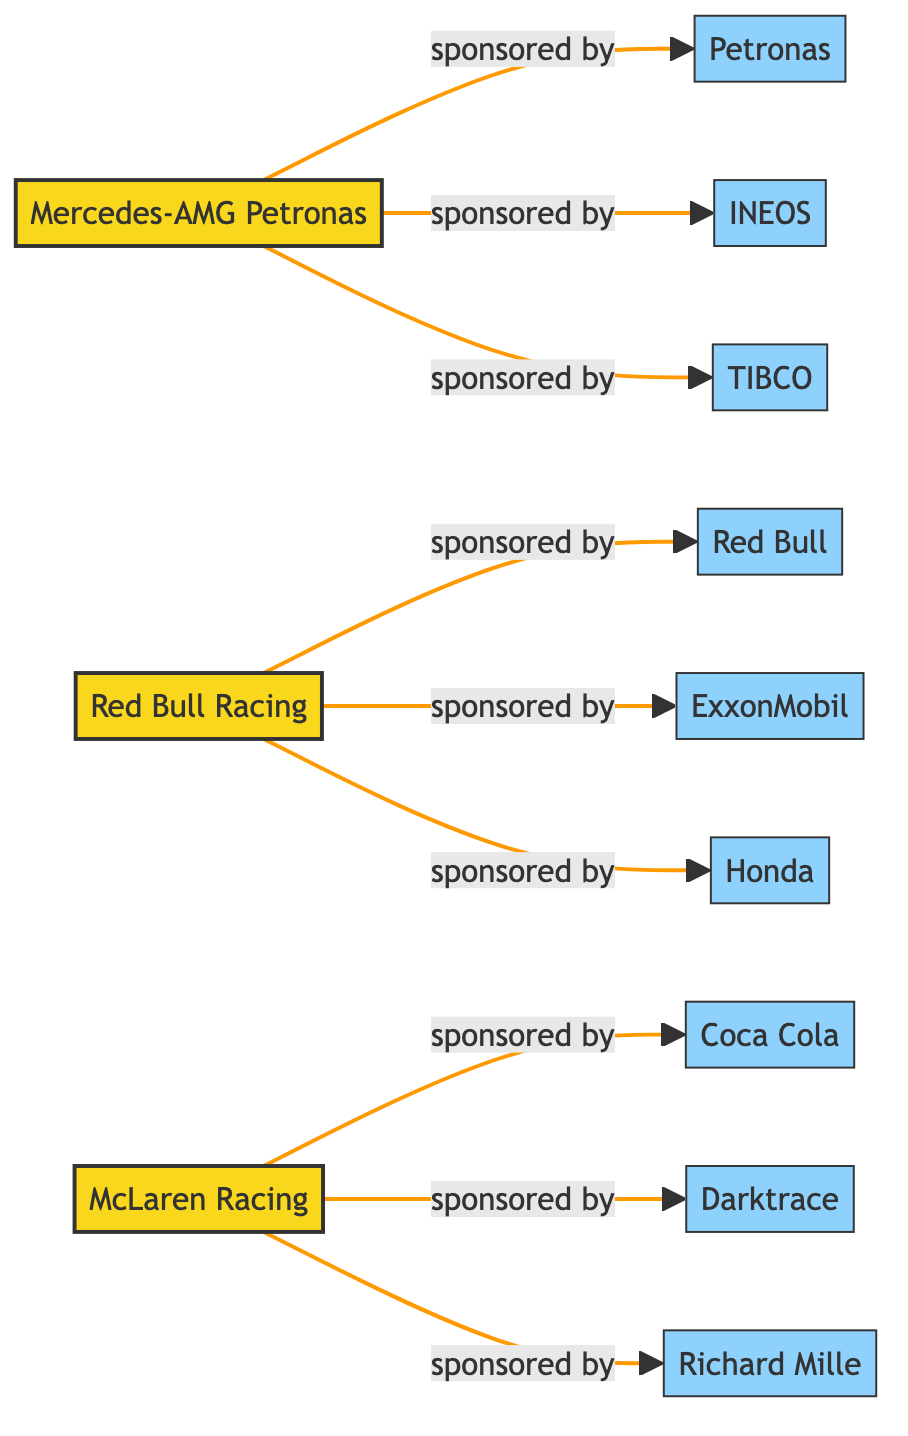What teams are featured in the diagram? The diagram lists three Formula 1 teams: Mercedes-AMG Petronas, Red Bull Racing, and McLaren Racing.
Answer: Mercedes-AMG Petronas, Red Bull Racing, McLaren Racing How many sponsors are represented in the diagram? By counting the nodes identified as sponsors, we find there are eight sponsors: Petronas, INEOS, TIBCO, Red Bull, ExxonMobil, Honda, Coca Cola, Darktrace, and Richard Mille.
Answer: eight Which team is sponsored by Honda? The diagram indicates that Red Bull Racing has Honda as a sponsor, represented by a link from Red Bull Racing to Honda.
Answer: Red Bull Racing How many sponsorships does McLaren Racing have? The links from McLaren Racing show three sponsorships: Coca Cola, Darktrace, and Richard Mille. Therefore, McLaren Racing is represented by three sponsorship connections.
Answer: three Which team has the most sponsors? By examining the connections, Mercedes-AMG Petronas has three sponsors (Petronas, INEOS, TIBCO), Red Bull Racing has three (Red Bull, ExxonMobil, Honda), and McLaren Racing also has three. All teams have equal sponsorship counts, making this a decision between them.
Answer: equal Which sponsor is linked to both Mercedes-AMG Petronas and McLaren Racing in the diagram? The diagram does not show any sponsor that is connected to both teams; each sponsor is exclusive to its respective team, like Petronas exclusively with Mercedes-AMG Petronas and Coca Cola exclusively with McLaren Racing.
Answer: none What type of relationship connects the teams to their sponsors? The relationship shown connecting the teams to their sponsors is defined as "sponsored by" in each of the links, clearly establishing the sponsorship nature between them.
Answer: sponsored by How many connections does Red Bull Racing have? Analyzing the links associated with Red Bull Racing reveals three connections: to Red Bull, ExxonMobil, and Honda, indicating its sponsorship relationships.
Answer: three 